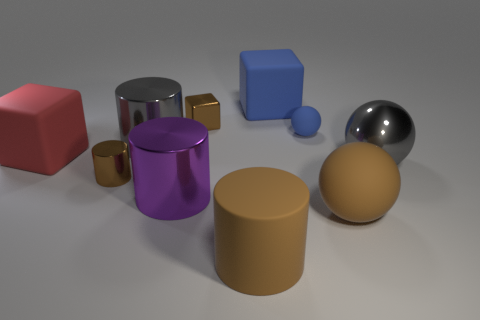What is the material of the block that is the same color as the small sphere?
Your answer should be very brief. Rubber. Do the red cube and the brown object right of the big rubber cylinder have the same material?
Offer a very short reply. Yes. There is another block that is the same size as the red matte cube; what is its material?
Provide a short and direct response. Rubber. Are there any brown cylinders that have the same size as the red rubber thing?
Ensure brevity in your answer.  Yes. There is a purple metal object that is the same size as the red rubber object; what is its shape?
Offer a very short reply. Cylinder. What number of other objects are there of the same color as the large rubber sphere?
Your answer should be very brief. 3. What is the shape of the big rubber thing that is both behind the big gray shiny sphere and on the right side of the red matte thing?
Give a very brief answer. Cube. There is a tiny brown thing that is behind the big gray metal object behind the large gray ball; is there a big purple metallic object behind it?
Give a very brief answer. No. What number of other objects are there of the same material as the red cube?
Offer a terse response. 4. What number of big blue matte blocks are there?
Offer a very short reply. 1. 